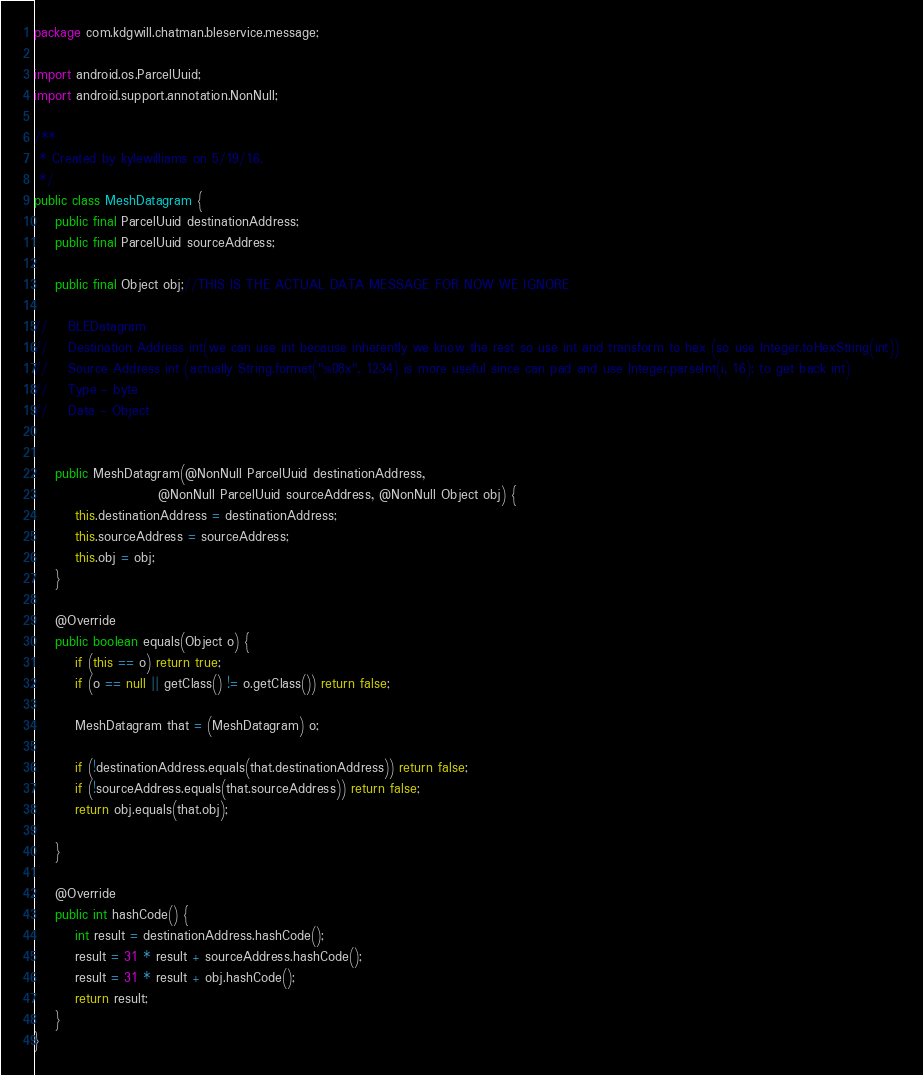Convert code to text. <code><loc_0><loc_0><loc_500><loc_500><_Java_>package com.kdgwill.chatman.bleservice.message;

import android.os.ParcelUuid;
import android.support.annotation.NonNull;

/**
 * Created by kylewilliams on 5/19/16.
 */
public class MeshDatagram {
    public final ParcelUuid destinationAddress;
    public final ParcelUuid sourceAddress;

    public final Object obj;//THIS IS THE ACTUAL DATA MESSAGE FOR NOW WE IGNORE

//    BLEDatagram
//    Destination Address int(we can use int because inherently we know the rest so use int and transform to hex (so use Integer.toHexString(int))
//    Source Address int (actually String.format("%08x", 1234) is more useful since can pad and use Integer.parseInt(i, 16); to get back int)
//    Type - byte
//    Data - Object


    public MeshDatagram(@NonNull ParcelUuid destinationAddress,
                        @NonNull ParcelUuid sourceAddress, @NonNull Object obj) {
        this.destinationAddress = destinationAddress;
        this.sourceAddress = sourceAddress;
        this.obj = obj;
    }

    @Override
    public boolean equals(Object o) {
        if (this == o) return true;
        if (o == null || getClass() != o.getClass()) return false;

        MeshDatagram that = (MeshDatagram) o;

        if (!destinationAddress.equals(that.destinationAddress)) return false;
        if (!sourceAddress.equals(that.sourceAddress)) return false;
        return obj.equals(that.obj);

    }

    @Override
    public int hashCode() {
        int result = destinationAddress.hashCode();
        result = 31 * result + sourceAddress.hashCode();
        result = 31 * result + obj.hashCode();
        return result;
    }
}
</code> 